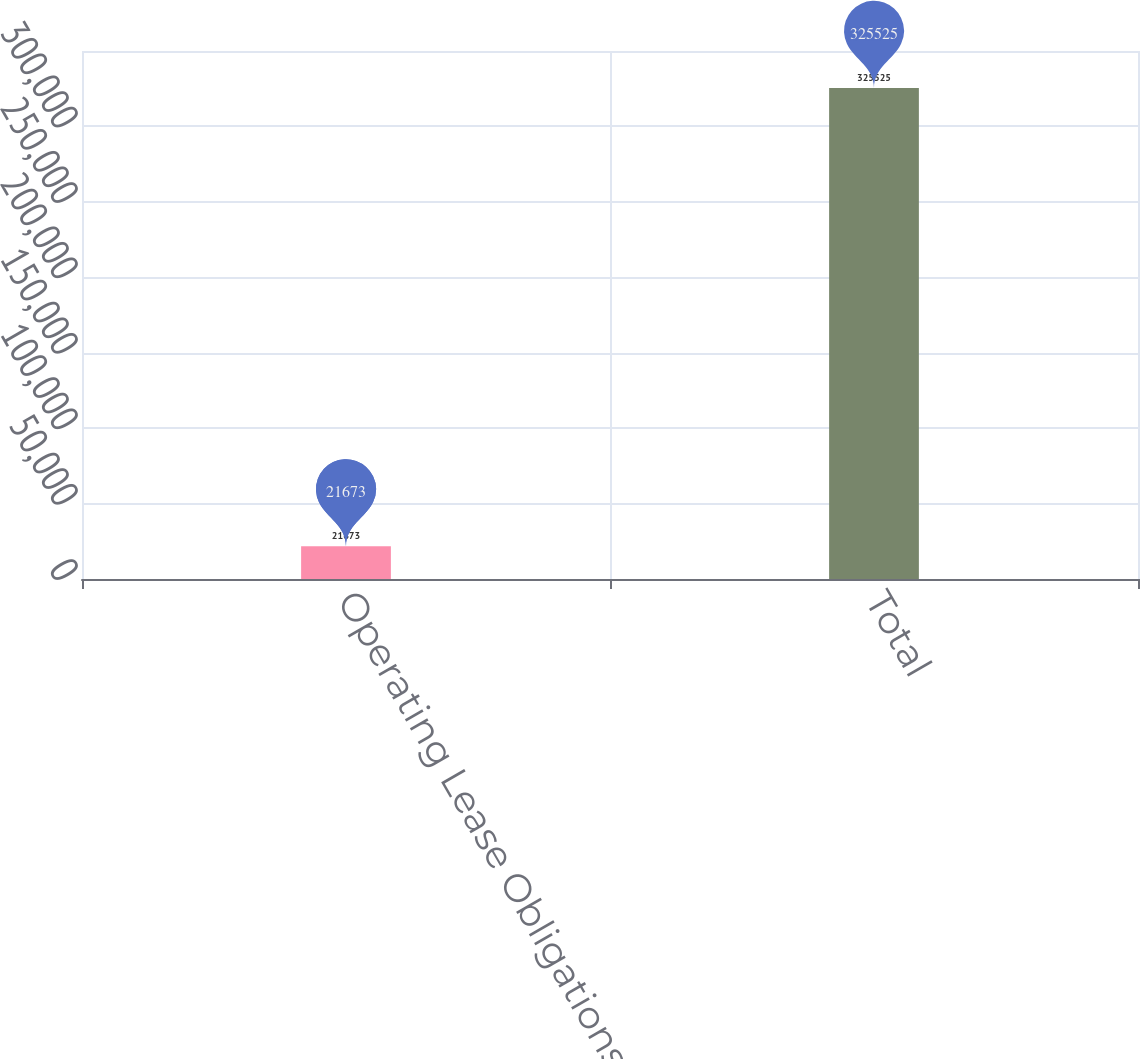Convert chart to OTSL. <chart><loc_0><loc_0><loc_500><loc_500><bar_chart><fcel>Operating Lease Obligations<fcel>Total<nl><fcel>21673<fcel>325525<nl></chart> 